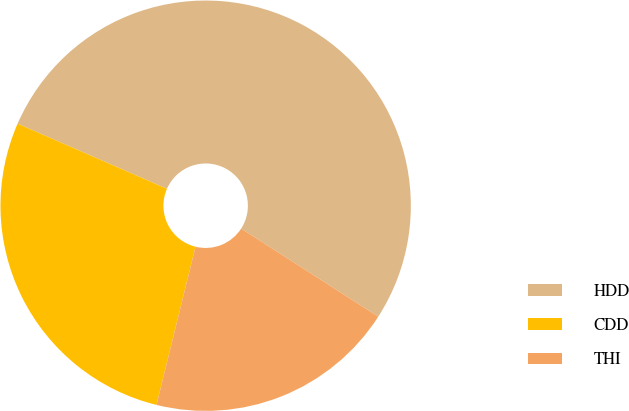Convert chart to OTSL. <chart><loc_0><loc_0><loc_500><loc_500><pie_chart><fcel>HDD<fcel>CDD<fcel>THI<nl><fcel>52.55%<fcel>27.7%<fcel>19.76%<nl></chart> 